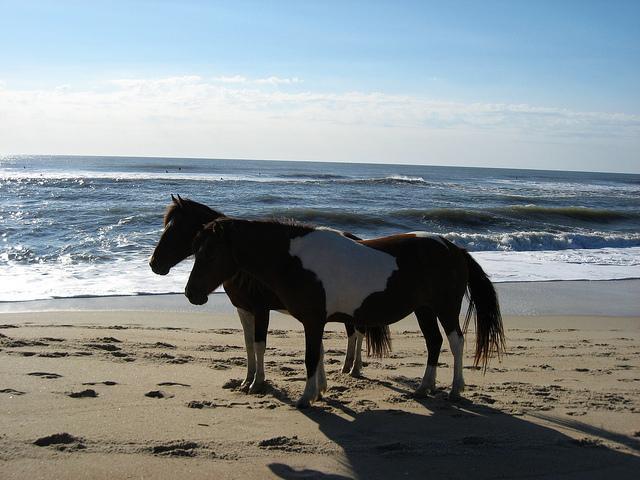How many horses are there?
Give a very brief answer. 2. How many horses are in the picture?
Give a very brief answer. 2. 